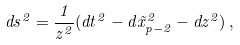Convert formula to latex. <formula><loc_0><loc_0><loc_500><loc_500>d s ^ { 2 } = \frac { 1 } { z ^ { 2 } } ( d t ^ { 2 } - d \vec { x } _ { p - 2 } ^ { 2 } - d z ^ { 2 } ) \, ,</formula> 